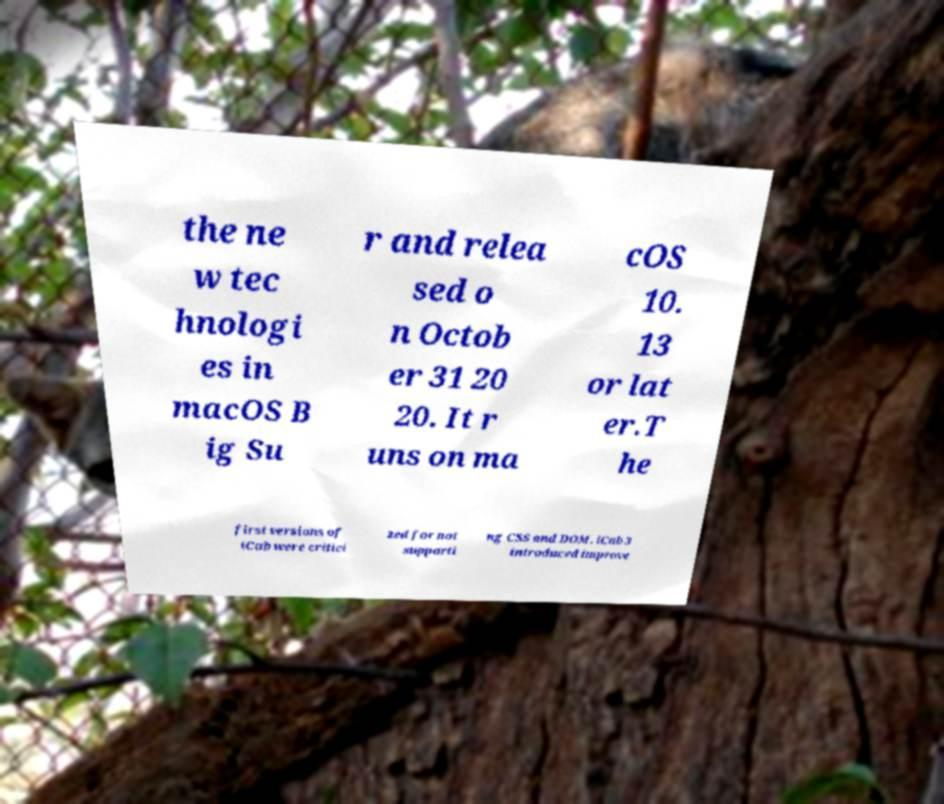Please identify and transcribe the text found in this image. the ne w tec hnologi es in macOS B ig Su r and relea sed o n Octob er 31 20 20. It r uns on ma cOS 10. 13 or lat er.T he first versions of iCab were critici zed for not supporti ng CSS and DOM. iCab 3 introduced improve 